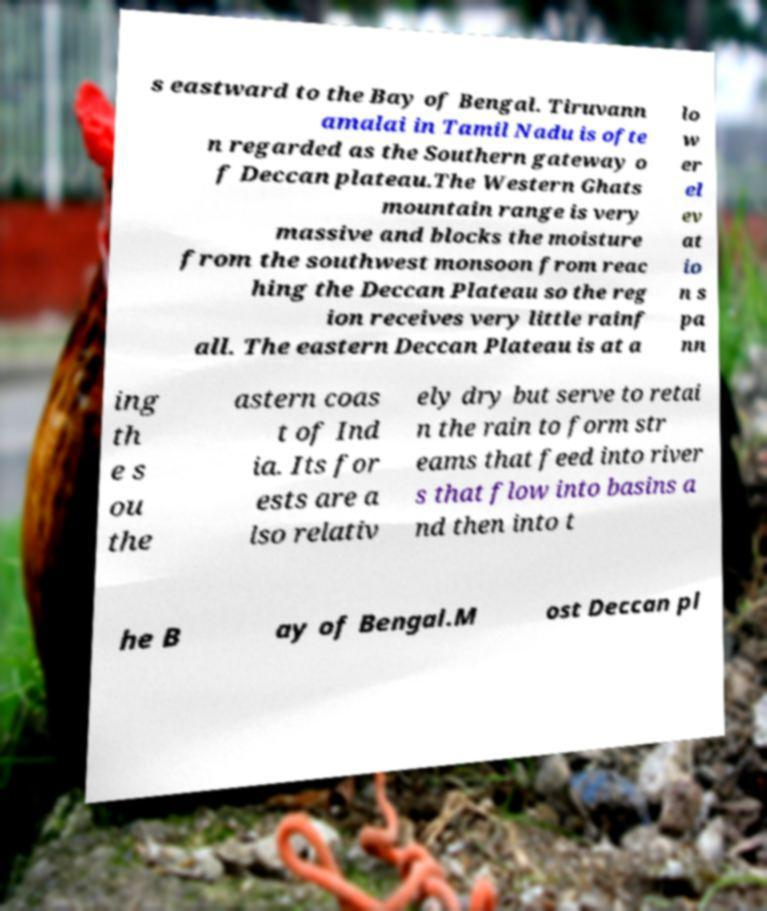For documentation purposes, I need the text within this image transcribed. Could you provide that? s eastward to the Bay of Bengal. Tiruvann amalai in Tamil Nadu is ofte n regarded as the Southern gateway o f Deccan plateau.The Western Ghats mountain range is very massive and blocks the moisture from the southwest monsoon from reac hing the Deccan Plateau so the reg ion receives very little rainf all. The eastern Deccan Plateau is at a lo w er el ev at io n s pa nn ing th e s ou the astern coas t of Ind ia. Its for ests are a lso relativ ely dry but serve to retai n the rain to form str eams that feed into river s that flow into basins a nd then into t he B ay of Bengal.M ost Deccan pl 